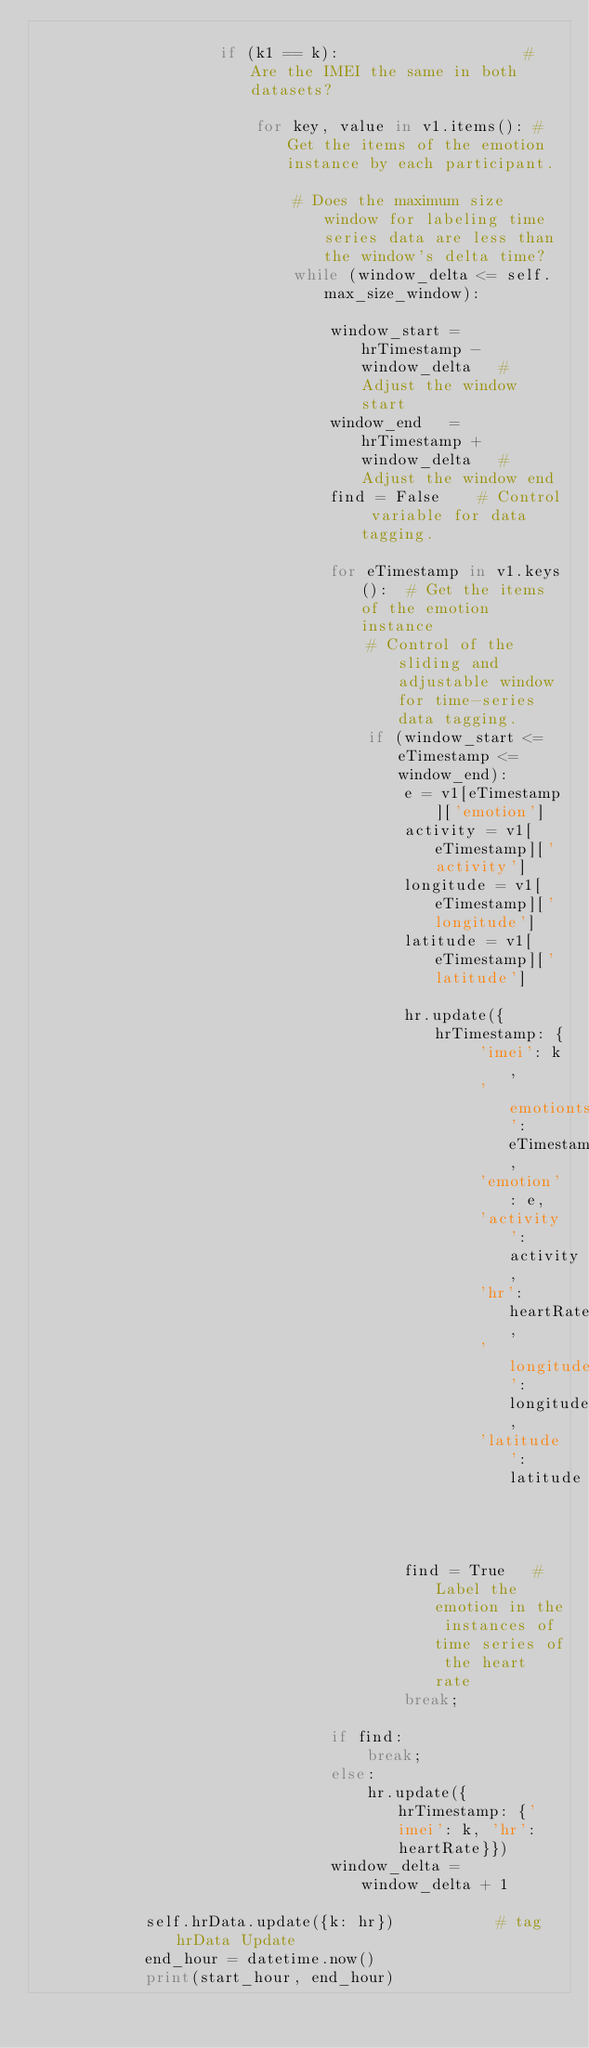Convert code to text. <code><loc_0><loc_0><loc_500><loc_500><_Python_>                       
                    if (k1 == k):                    # Are the IMEI the same in both datasets?
                        
                        for key, value in v1.items(): # Get the items of the emotion instance by each participant.
                            
                            # Does the maximum size window for labeling time series data are less than the window's delta time?
                            while (window_delta <= self.max_size_window): 
                                
                                window_start =  hrTimestamp - window_delta   # Adjust the window start
                                window_end   =  hrTimestamp + window_delta   # Adjust the window end
                                find = False    # Control variable for data tagging. 
                                
                                for eTimestamp in v1.keys():  # Get the items of the emotion instance
                                    # Control of the sliding and adjustable window for time-series data tagging.
                                    if (window_start <= eTimestamp <= window_end): 
                                        e = v1[eTimestamp]['emotion']
                                        activity = v1[eTimestamp]['activity']
                                        longitude = v1[eTimestamp]['longitude']
                                        latitude = v1[eTimestamp]['latitude']
                                        
                                        hr.update({hrTimestamp: {
                                                'imei': k,
                                                'emotionts': eTimestamp,
                                                'emotion': e,
                                                'activity': activity,
                                                'hr': heartRate,
                                                'longitude': longitude,
                                                'latitude': latitude
                                                                 }}); 
                                        find = True   # Label the emotion in the instances of time series of the heart rate
                                        break;
                            
                                if find:
                                    break;
                                else:
                                    hr.update({hrTimestamp: {'imei': k, 'hr': heartRate}})
                                window_delta = window_delta + 1
            
            self.hrData.update({k: hr})           # tag hrData Update
            end_hour = datetime.now()
            print(start_hour, end_hour)
</code> 